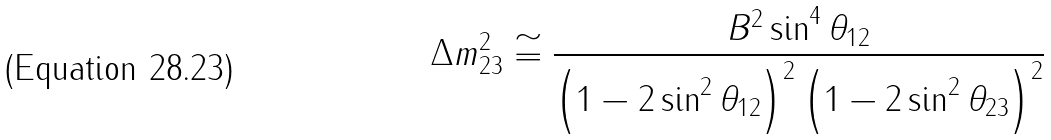<formula> <loc_0><loc_0><loc_500><loc_500>\Delta m _ { 2 3 } ^ { 2 } \cong \frac { B ^ { 2 } \sin ^ { 4 } \theta _ { 1 2 } } { \left ( 1 - 2 \sin ^ { 2 } \theta _ { 1 2 } \right ) ^ { 2 } \left ( 1 - 2 \sin ^ { 2 } \theta _ { 2 3 } \right ) ^ { 2 } }</formula> 